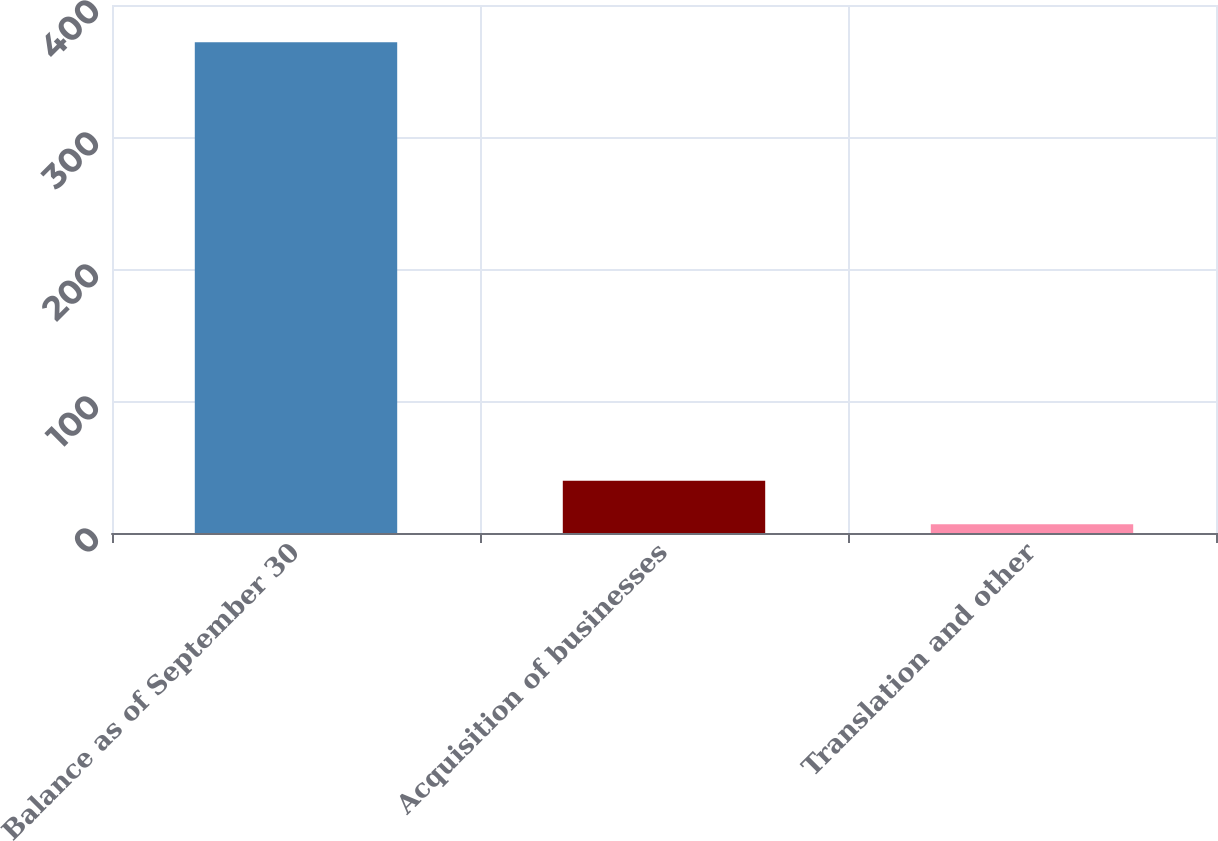Convert chart to OTSL. <chart><loc_0><loc_0><loc_500><loc_500><bar_chart><fcel>Balance as of September 30<fcel>Acquisition of businesses<fcel>Translation and other<nl><fcel>371.78<fcel>39.54<fcel>6.7<nl></chart> 